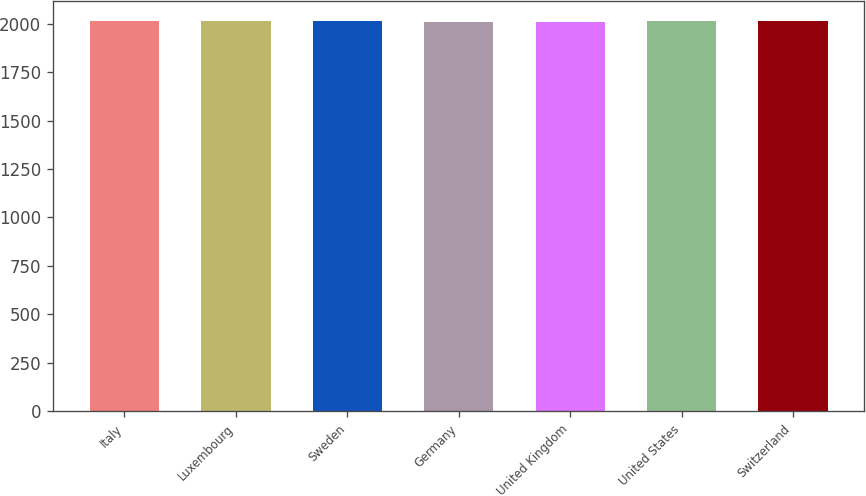<chart> <loc_0><loc_0><loc_500><loc_500><bar_chart><fcel>Italy<fcel>Luxembourg<fcel>Sweden<fcel>Germany<fcel>United Kingdom<fcel>United States<fcel>Switzerland<nl><fcel>2012<fcel>2014<fcel>2012.4<fcel>2010<fcel>2010.4<fcel>2014.4<fcel>2012.8<nl></chart> 